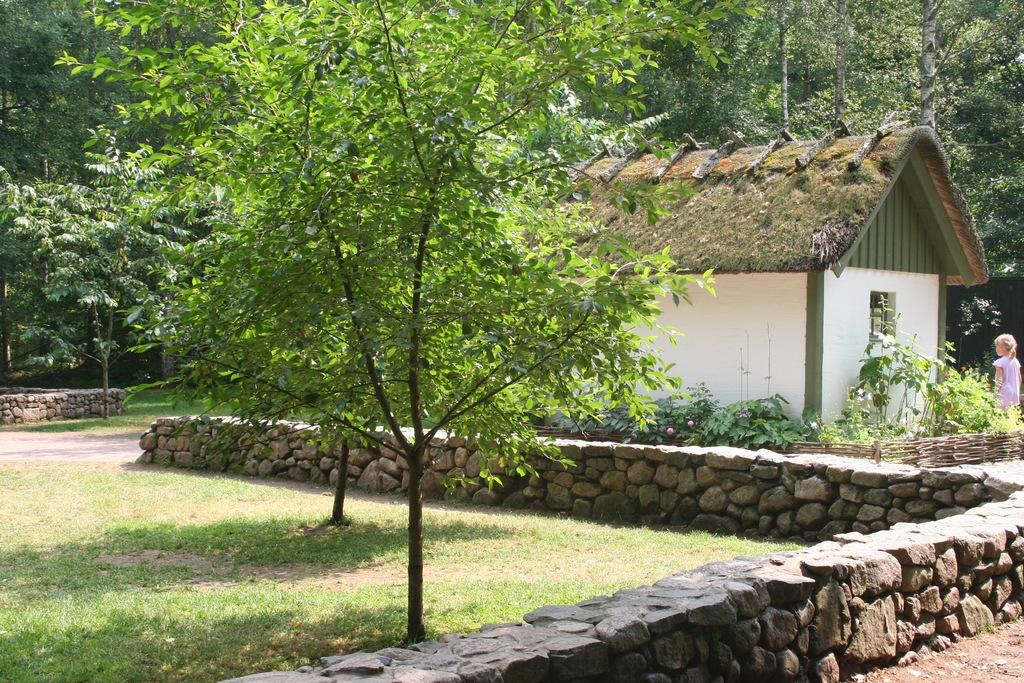What type of vegetation can be seen in the image? There is grass, plants, and trees in the image. What other objects or features are present in the image? There are rocks and a house in the image. Are there any people in the image? Yes, there is a girl standing in the image. What color is the shirt the girl is wearing in the image? There is no mention of a shirt or any clothing in the provided facts. 